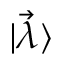<formula> <loc_0><loc_0><loc_500><loc_500>| \vec { \lambda } \rangle</formula> 